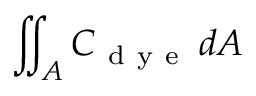<formula> <loc_0><loc_0><loc_500><loc_500>\iint _ { A } C _ { d y e } \, d A</formula> 